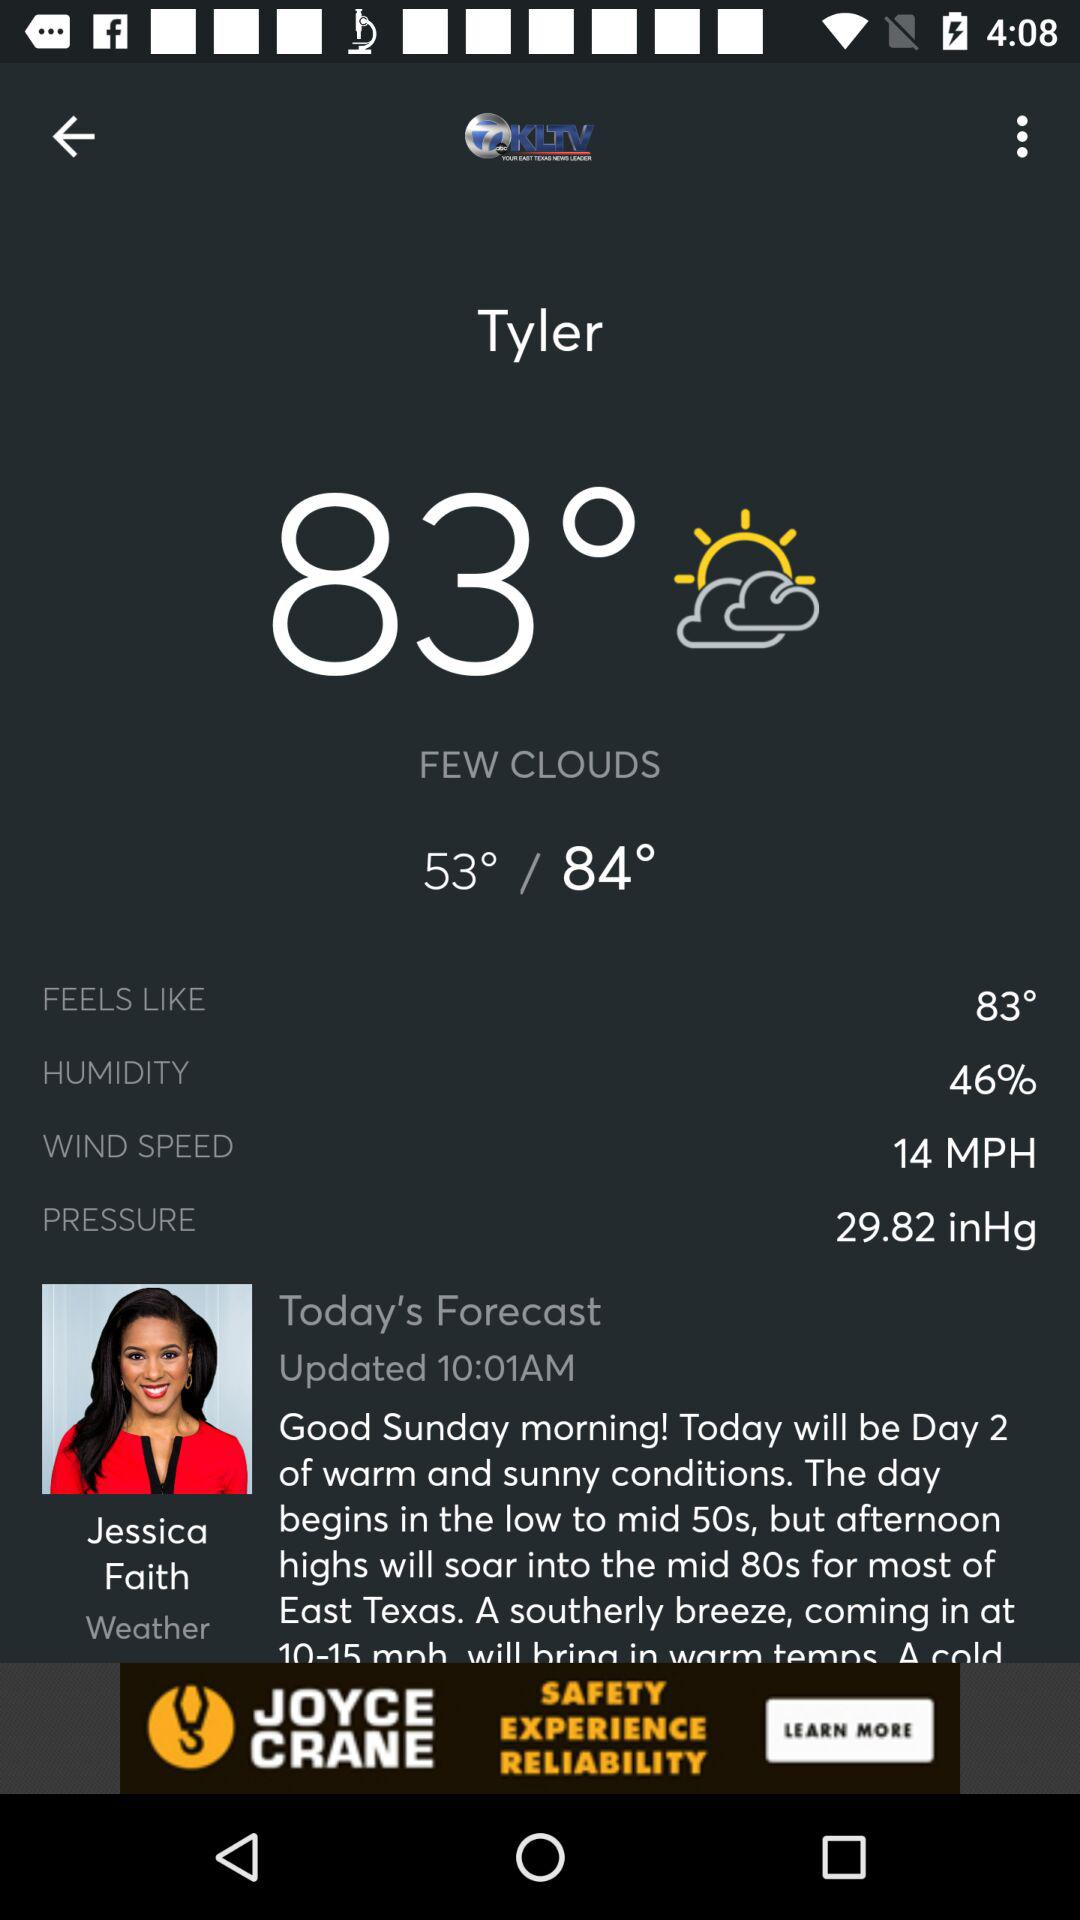How much higher is the high temperature than the low temperature?
Answer the question using a single word or phrase. 31° 